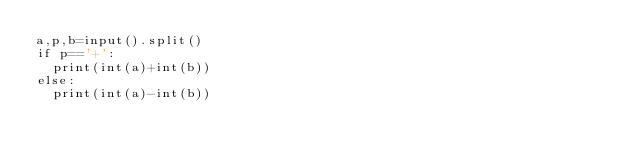Convert code to text. <code><loc_0><loc_0><loc_500><loc_500><_Python_>a,p,b=input().split()
if p=='+':
  print(int(a)+int(b))
else:
  print(int(a)-int(b))</code> 